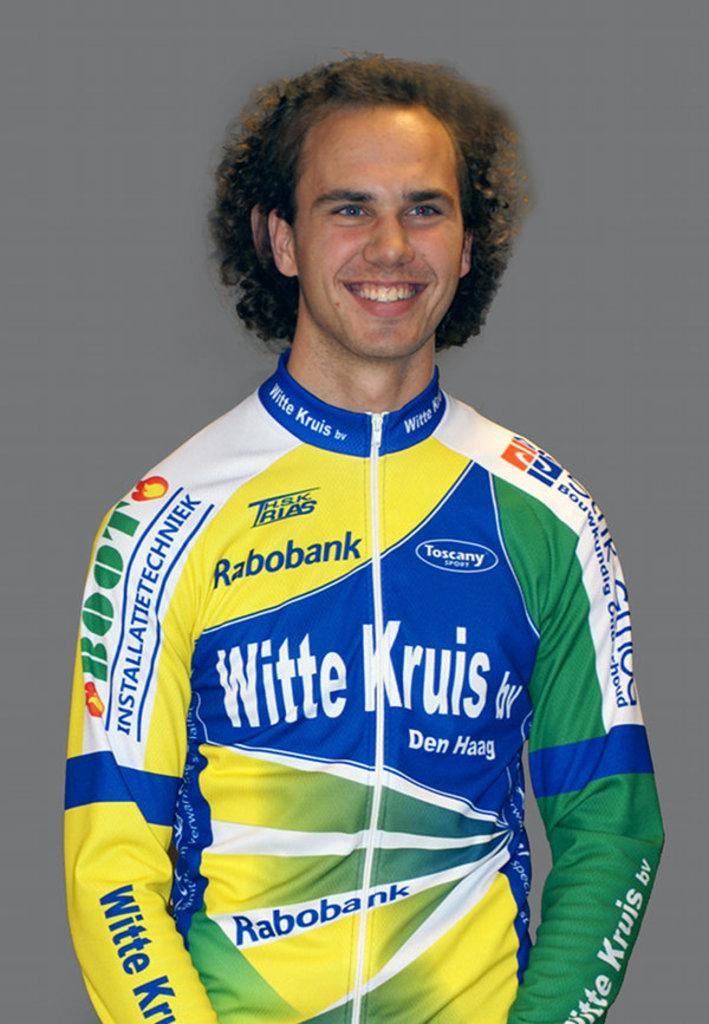<image>
Describe the image concisely. A man wearing a jumpsuit with ads from Witte Kruis and others. 